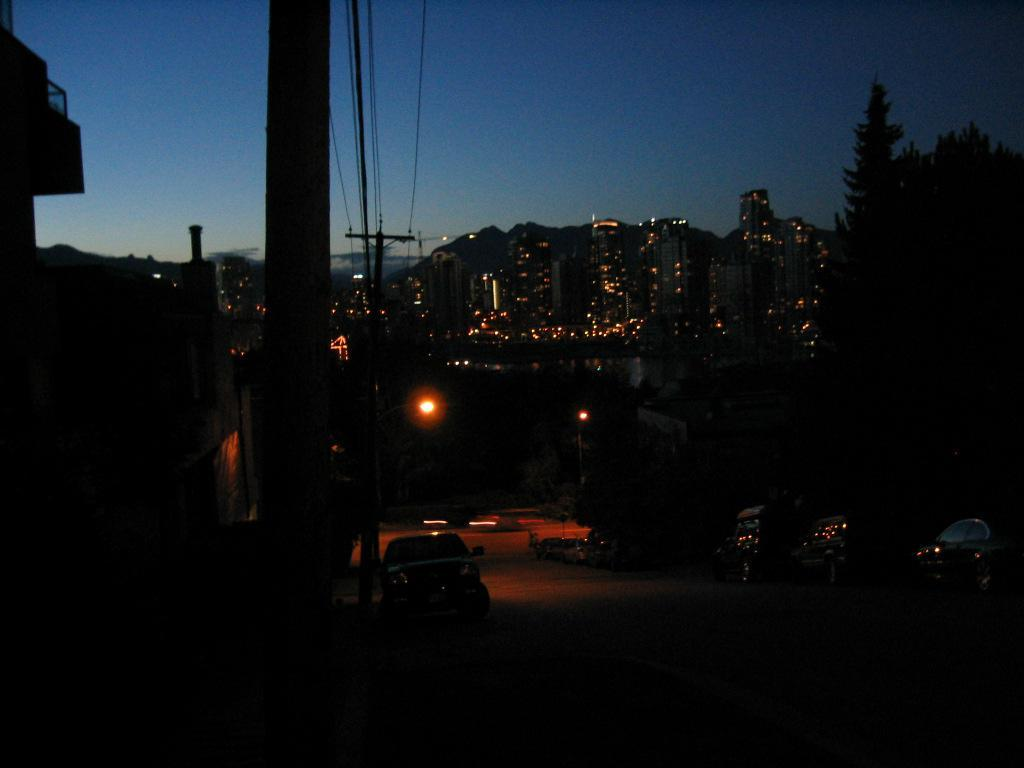What can be seen on the road in the image? There are vehicles on the road in the image. What objects are present in the image that support or hold something? There are poles in the image. What can be seen illuminating the area in the image? There are lights in the image. What type of vegetation is visible in the image? There are trees in the image. What is present in the image that connects various objects or structures? There are cables in the image. What type of man-made structures are visible in the image? There are buildings in the image. What is visible in the background of the image? The sky is visible in the background of the image. Can you tell me how many cords are connected to the grandmother in the image? There is no grandmother present in the image, and therefore no cords can be connected to her. What type of smoke is visible coming from the vehicles in the image? There is no smoke visible coming from the vehicles in the image. 